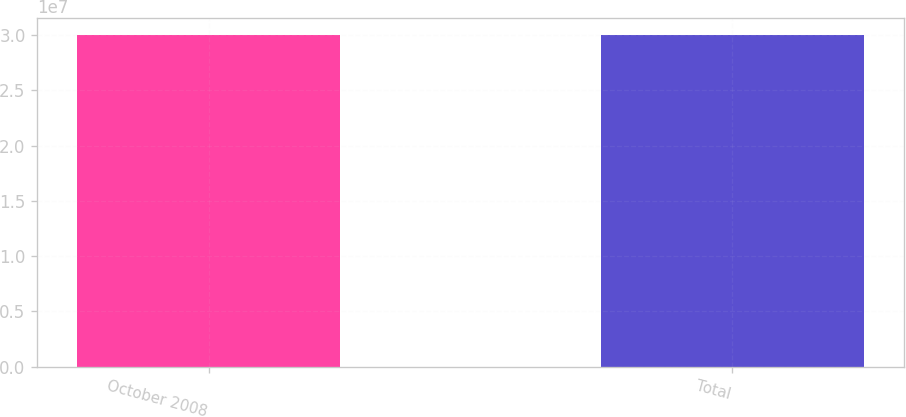Convert chart. <chart><loc_0><loc_0><loc_500><loc_500><bar_chart><fcel>October 2008<fcel>Total<nl><fcel>3.00665e+07<fcel>3.00665e+07<nl></chart> 